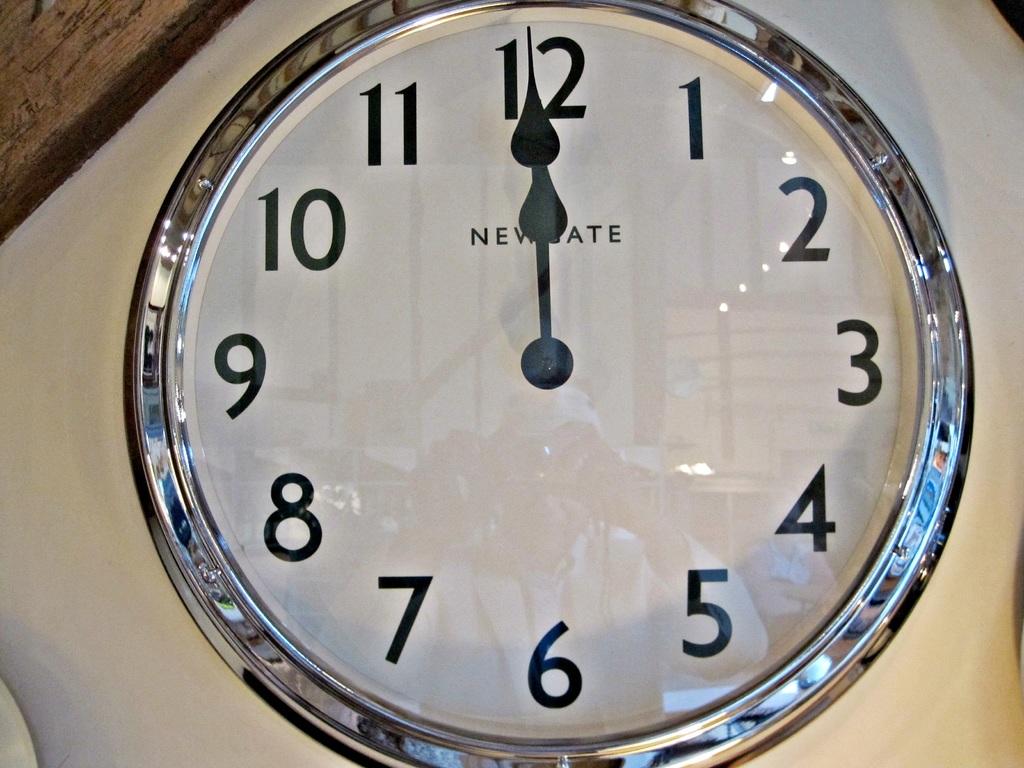What time does the clock say it is?
Your response must be concise. 12:00. What is the highest number on this photo?
Your answer should be compact. 12. 